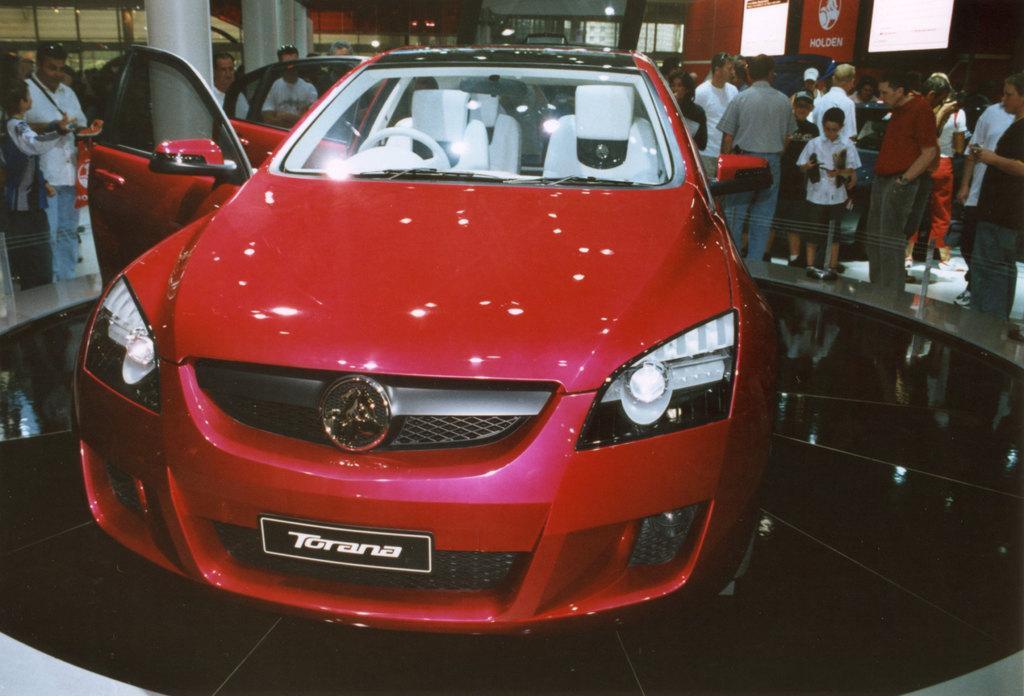Please provide a concise description of this image. In this image we can see a car, which is red in color and we can see two doors are open and on the plate we can see a name called Torana and there are lot of spectators watching the car. 